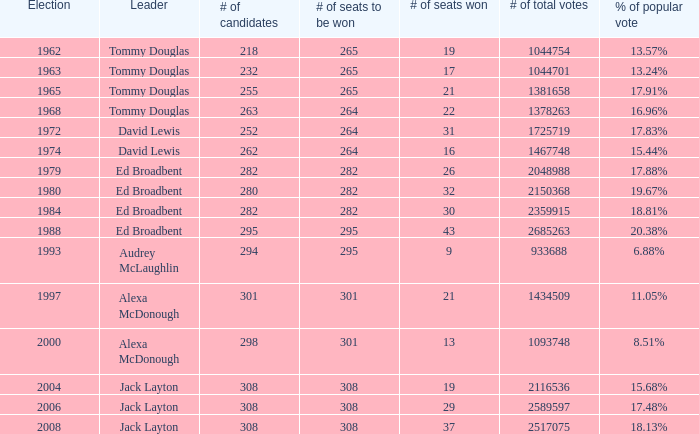With a popular vote percentage of 6.88%, how many seats are up for grabs? 295.0. Write the full table. {'header': ['Election', 'Leader', '# of candidates', '# of seats to be won', '# of seats won', '# of total votes', '% of popular vote'], 'rows': [['1962', 'Tommy Douglas', '218', '265', '19', '1044754', '13.57%'], ['1963', 'Tommy Douglas', '232', '265', '17', '1044701', '13.24%'], ['1965', 'Tommy Douglas', '255', '265', '21', '1381658', '17.91%'], ['1968', 'Tommy Douglas', '263', '264', '22', '1378263', '16.96%'], ['1972', 'David Lewis', '252', '264', '31', '1725719', '17.83%'], ['1974', 'David Lewis', '262', '264', '16', '1467748', '15.44%'], ['1979', 'Ed Broadbent', '282', '282', '26', '2048988', '17.88%'], ['1980', 'Ed Broadbent', '280', '282', '32', '2150368', '19.67%'], ['1984', 'Ed Broadbent', '282', '282', '30', '2359915', '18.81%'], ['1988', 'Ed Broadbent', '295', '295', '43', '2685263', '20.38%'], ['1993', 'Audrey McLaughlin', '294', '295', '9', '933688', '6.88%'], ['1997', 'Alexa McDonough', '301', '301', '21', '1434509', '11.05%'], ['2000', 'Alexa McDonough', '298', '301', '13', '1093748', '8.51%'], ['2004', 'Jack Layton', '308', '308', '19', '2116536', '15.68%'], ['2006', 'Jack Layton', '308', '308', '29', '2589597', '17.48%'], ['2008', 'Jack Layton', '308', '308', '37', '2517075', '18.13%']]} 